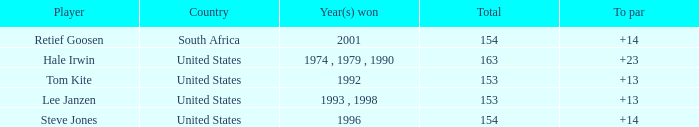What is the total that South Africa had a par greater than 14 None. 